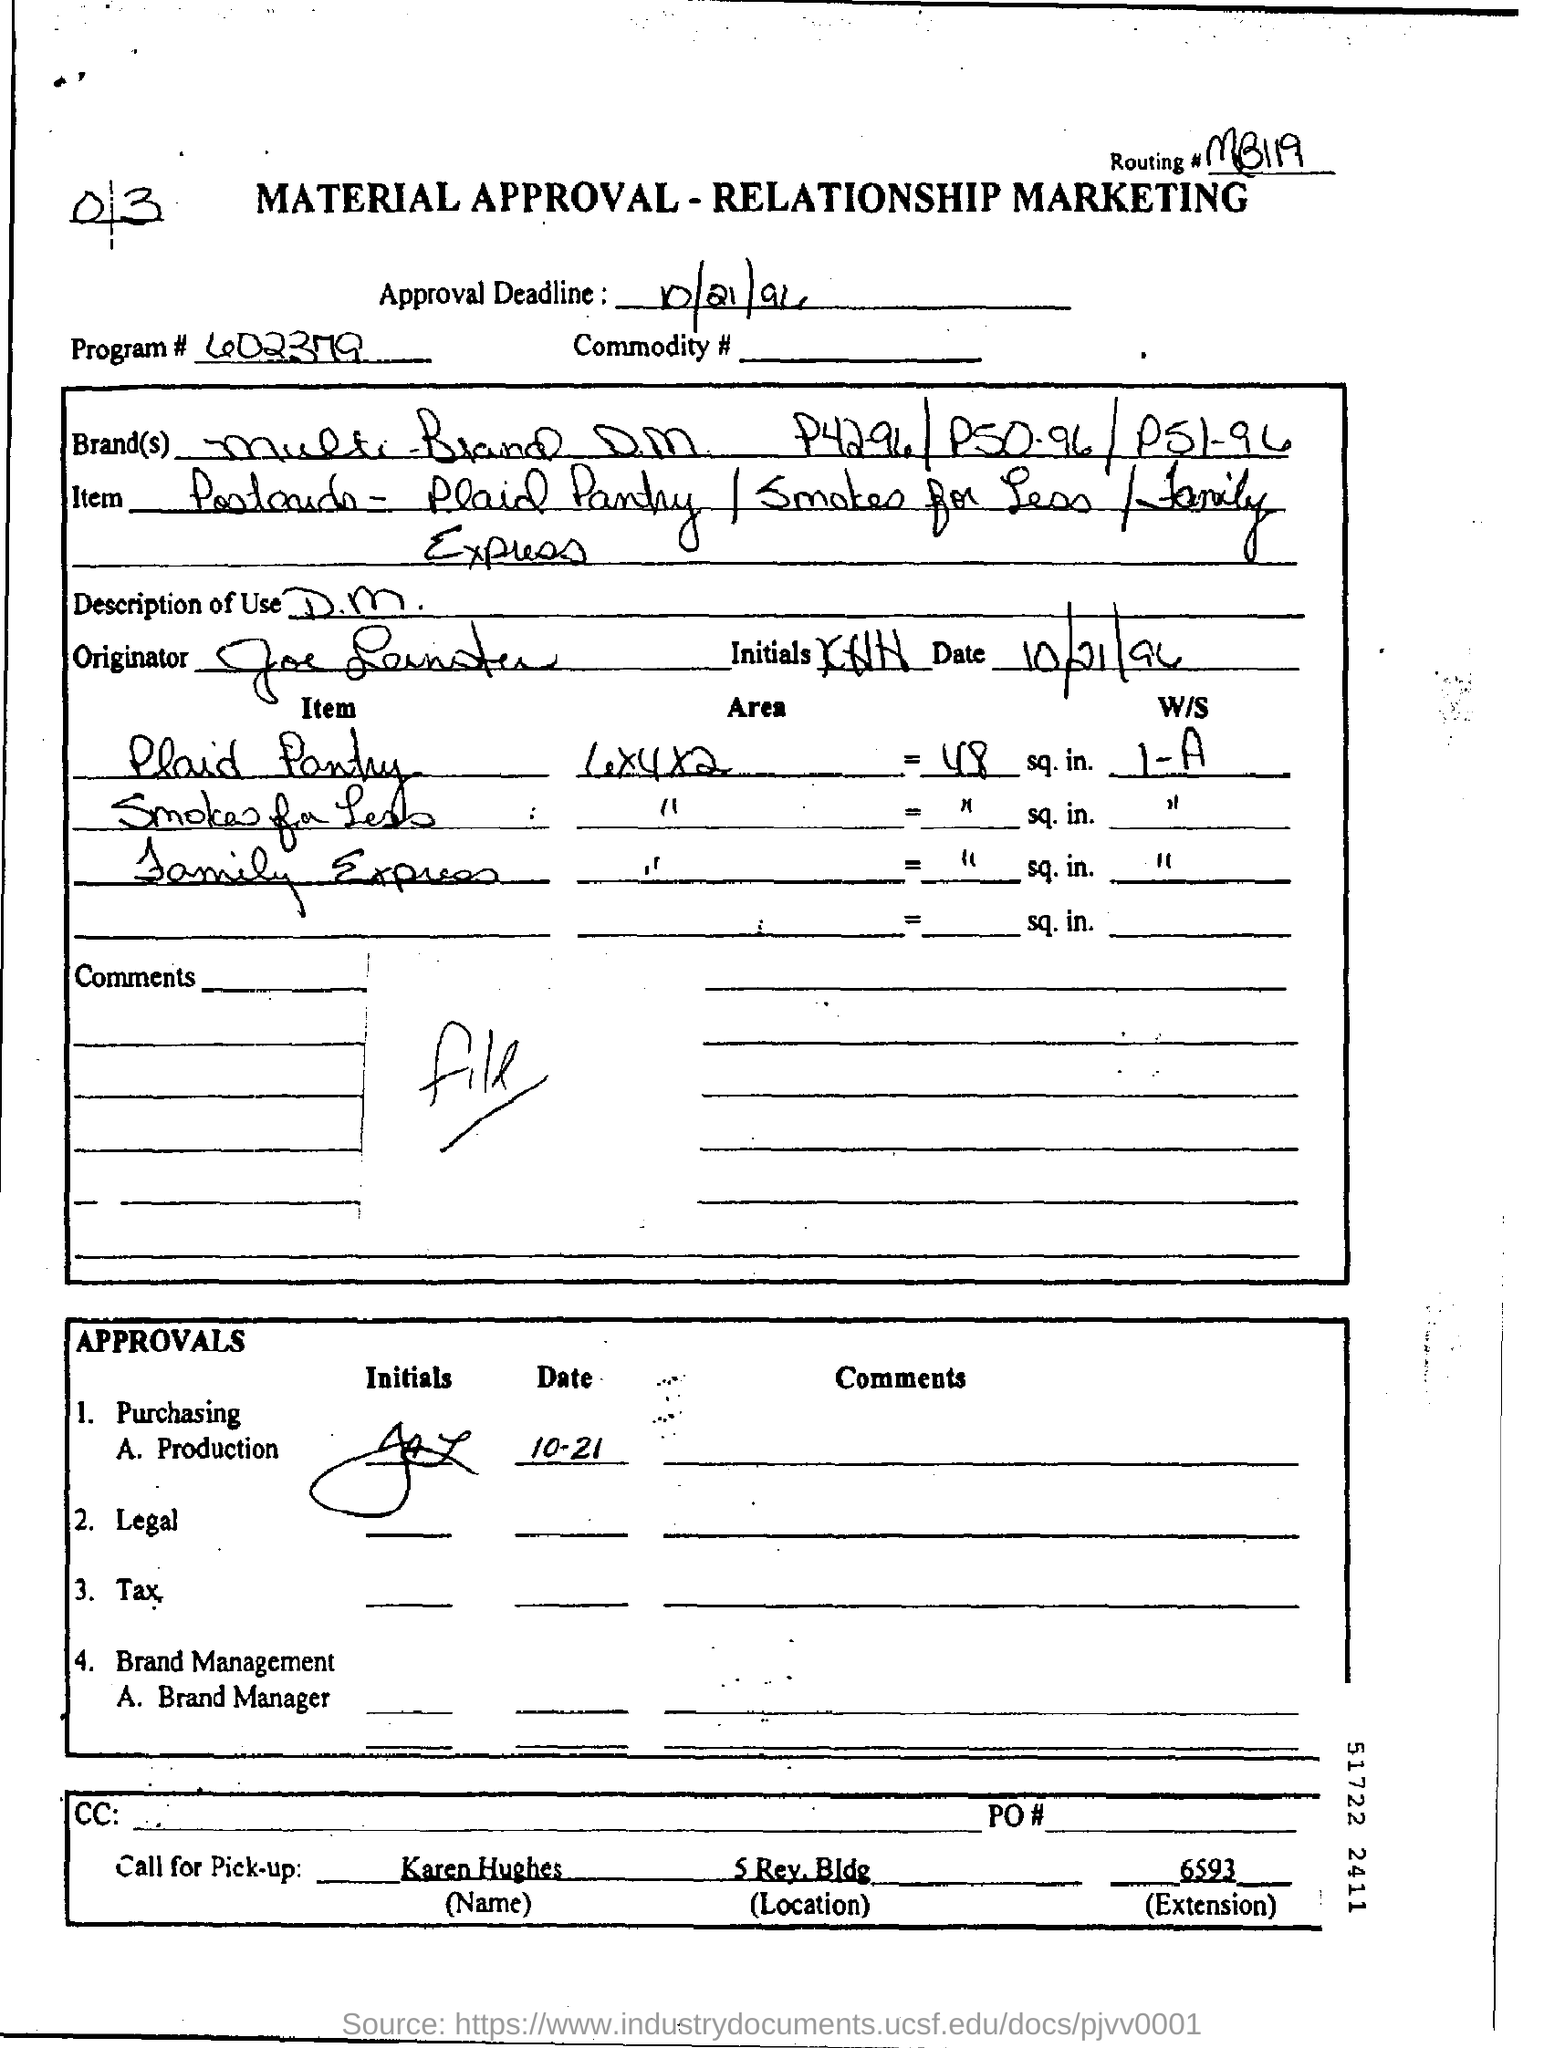Specify some key components in this picture. What is the routing number? It is MB119... The call for pick-up by the individual named Karen Hughes has been made. The program number is 602379... The approval deadline is on October 21, 1996. 